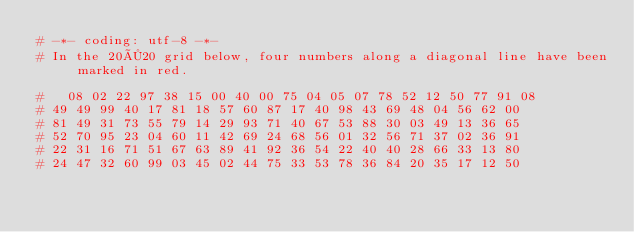<code> <loc_0><loc_0><loc_500><loc_500><_Ruby_># -*- coding: utf-8 -*-
# In the 20×20 grid below, four numbers along a diagonal line have been marked in red.

#   08 02 22 97 38 15 00 40 00 75 04 05 07 78 52 12 50 77 91 08
# 49 49 99 40 17 81 18 57 60 87 17 40 98 43 69 48 04 56 62 00
# 81 49 31 73 55 79 14 29 93 71 40 67 53 88 30 03 49 13 36 65
# 52 70 95 23 04 60 11 42 69 24 68 56 01 32 56 71 37 02 36 91
# 22 31 16 71 51 67 63 89 41 92 36 54 22 40 40 28 66 33 13 80
# 24 47 32 60 99 03 45 02 44 75 33 53 78 36 84 20 35 17 12 50</code> 